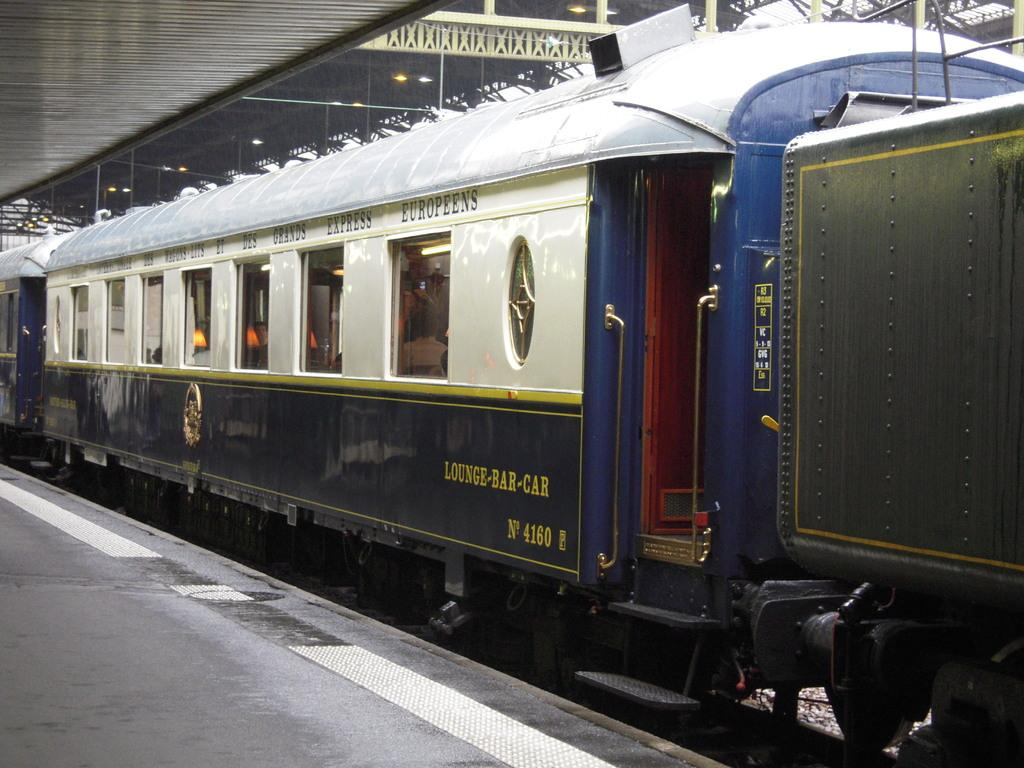<image>
Summarize the visual content of the image. A blue and white lounge-bar car sits on the tracks. 